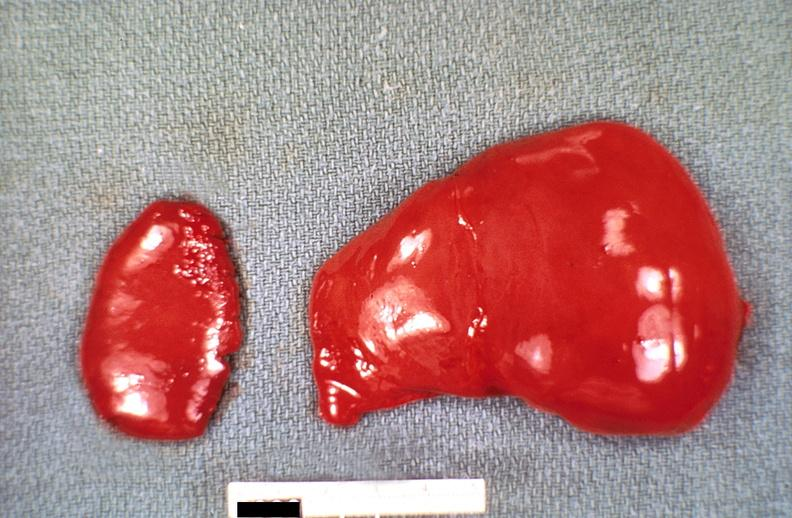does thyroid show liver and spleen, congestion, hemolytic disease of newborn?
Answer the question using a single word or phrase. No 